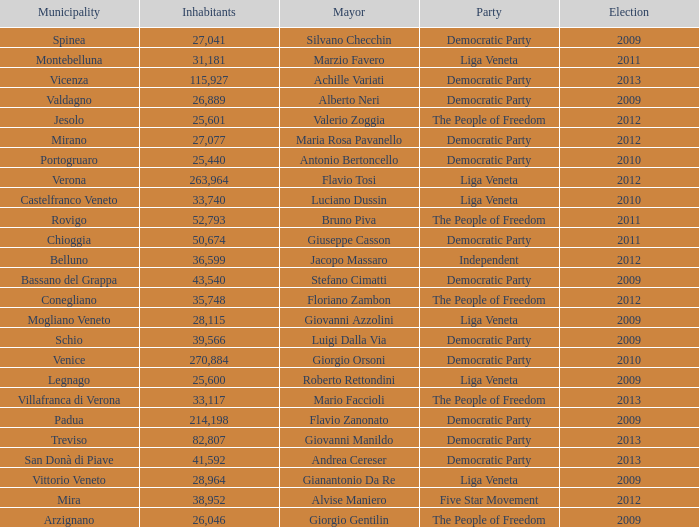In the election earlier than 2012 how many Inhabitants had a Party of five star movement? None. 